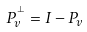Convert formula to latex. <formula><loc_0><loc_0><loc_500><loc_500>P _ { v } ^ { ^ { \perp } } = I - P _ { v }</formula> 